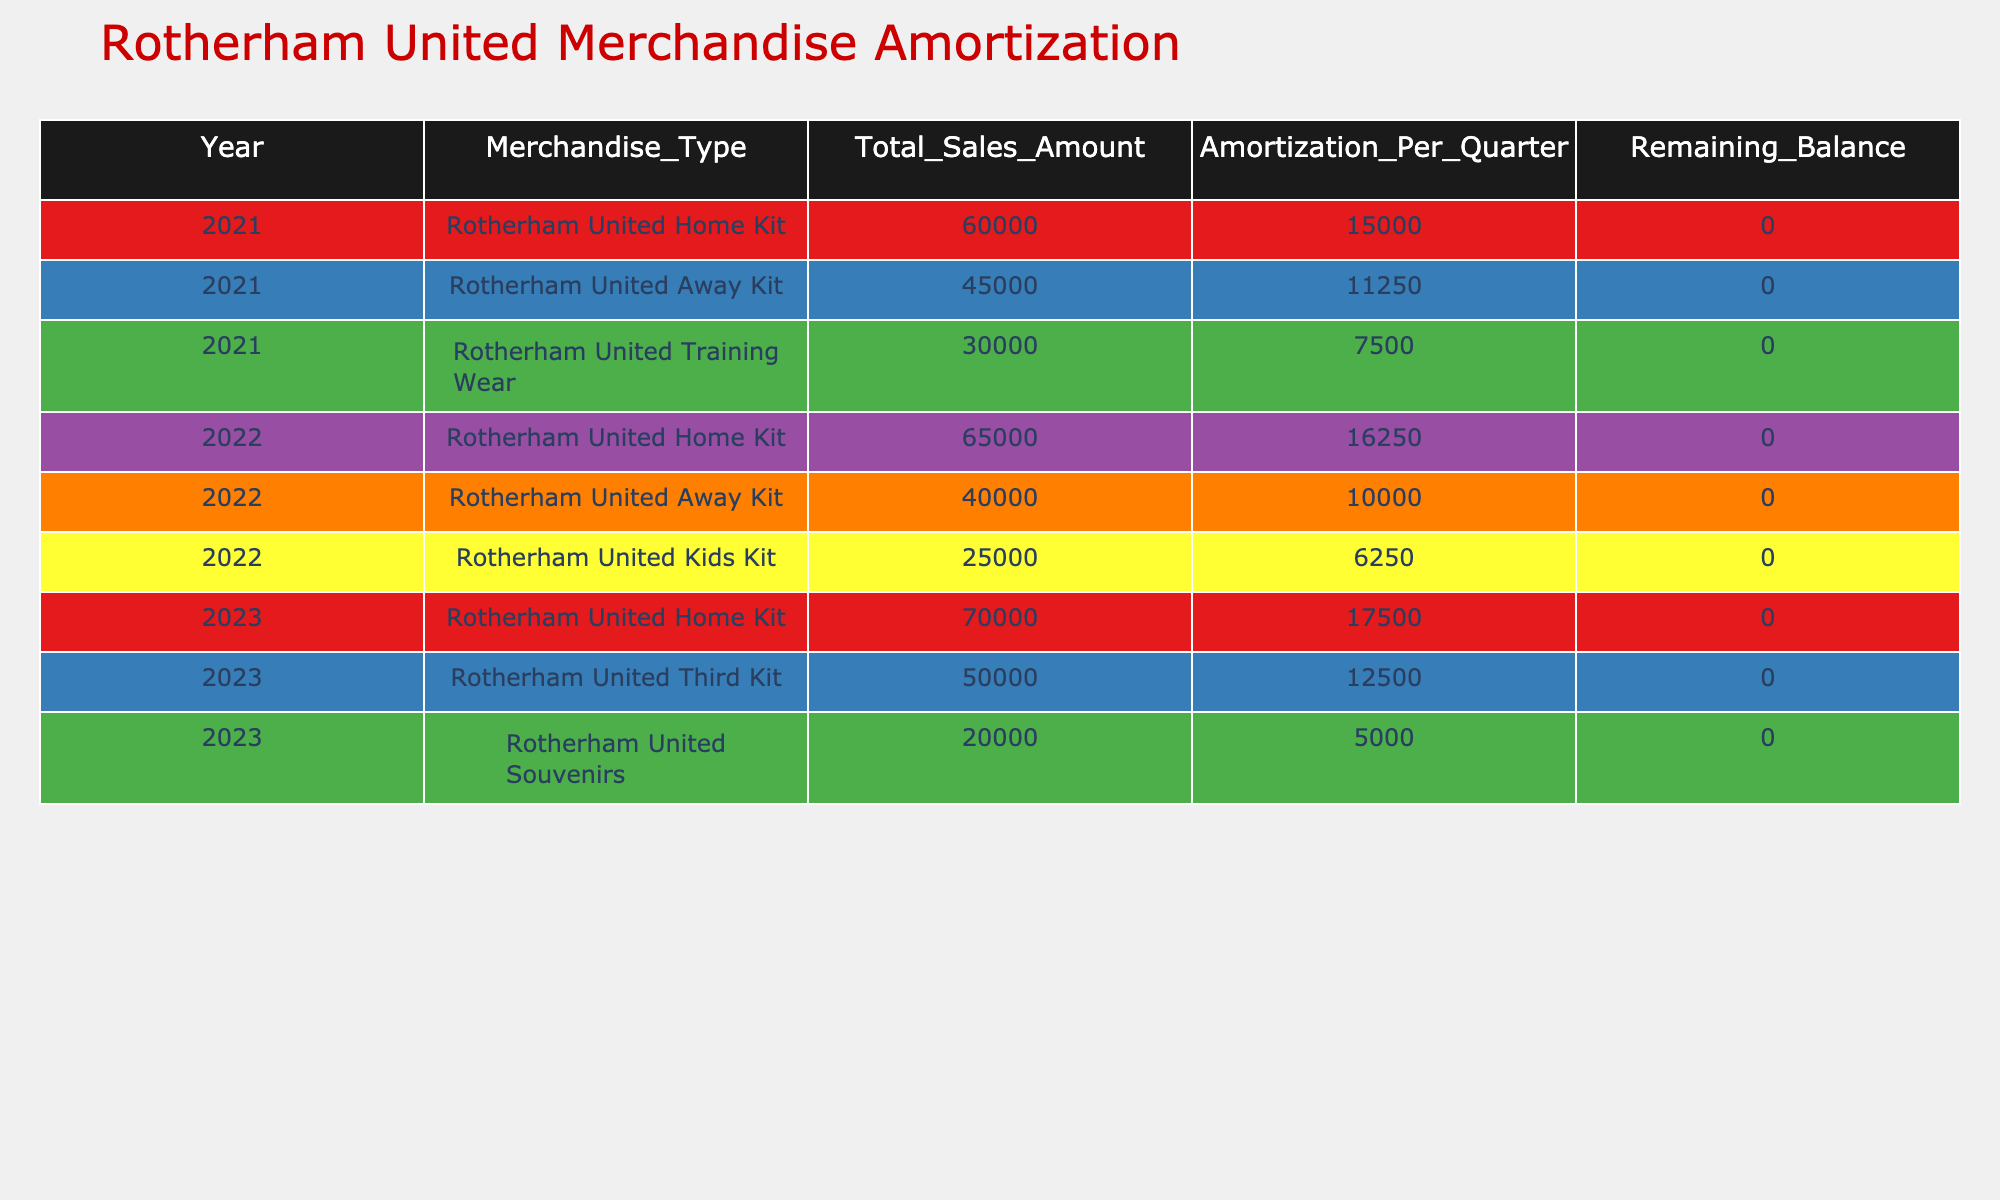What is the total sales amount for the Rotherham United Home Kit in 2021? The total sales amount for the Rotherham United Home Kit in 2021 is explicitly stated in the table, which shows 60,000.
Answer: 60,000 What is the amortization per quarter for the Rotherham United Away Kit in 2022? The table indicates that the amortization per quarter for the Rotherham United Away Kit in 2022 is 10,000.
Answer: 10,000 How much more revenue was generated from the Rotherham United Home Kit in 2023 compared to 2022? In 2023, the sales amount for the Rotherham United Home Kit is 70,000, while in 2022 it was 65,000. The difference is 70,000 - 65,000 = 5,000.
Answer: 5,000 Is the remaining balance for the merchandise types listed in 2021 equal to zero? The table shows that the remaining balance for all merchandise types listed in 2021 is indeed 0, confirming the statement is true.
Answer: Yes What is the total amortization amount for all merchandise types in 2021? The total amortization for 2021 can be found by adding the amortization per quarter for Rotherham United Home Kit (15,000), Away Kit (11,250), and Training Wear (7,500), which totals 15,000 + 11,250 + 7,500 = 33,750.
Answer: 33,750 How much total sales was made from Rotherham United Kids Kit in 2022? The total sales amount for the Rotherham United Kids Kit in 2022 is found in the table as 25,000.
Answer: 25,000 Was the amortization per quarter for the Rotherham United Training Wear in 2021 greater than 8,000? The table shows that the amortization per quarter for the Rotherham United Training Wear in 2021 is 7,500, which is less than 8,000, so the answer is false.
Answer: No What is the average amortization per quarter for all merchandise types sold in 2023? The amortization values for 2023 are 17,500 (Home Kit), 12,500 (Third Kit), and 5,000 (Souvenirs), totaling 35,000. There are 3 types, so the average is 35,000 / 3 = 11,666.67 rounded to two decimal places is approximately 11,667.
Answer: 11,667 